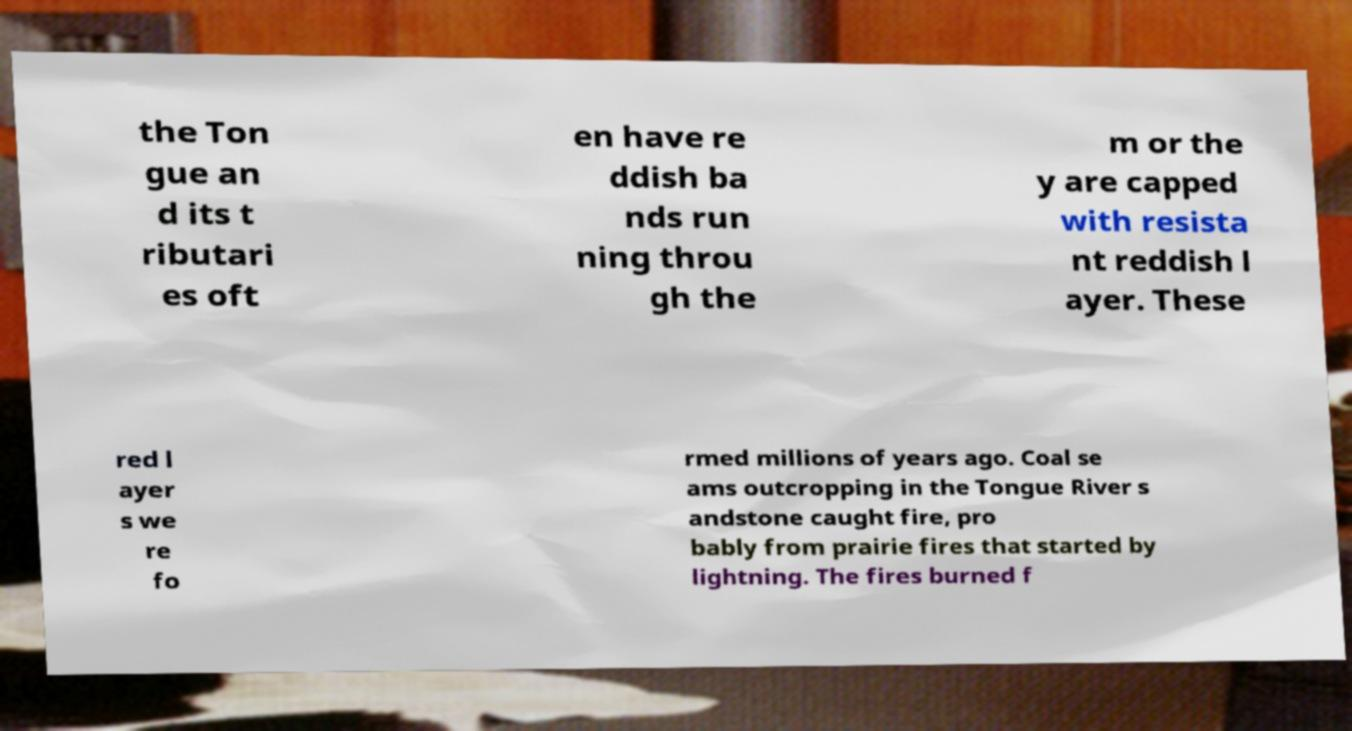Could you extract and type out the text from this image? the Ton gue an d its t ributari es oft en have re ddish ba nds run ning throu gh the m or the y are capped with resista nt reddish l ayer. These red l ayer s we re fo rmed millions of years ago. Coal se ams outcropping in the Tongue River s andstone caught fire, pro bably from prairie fires that started by lightning. The fires burned f 